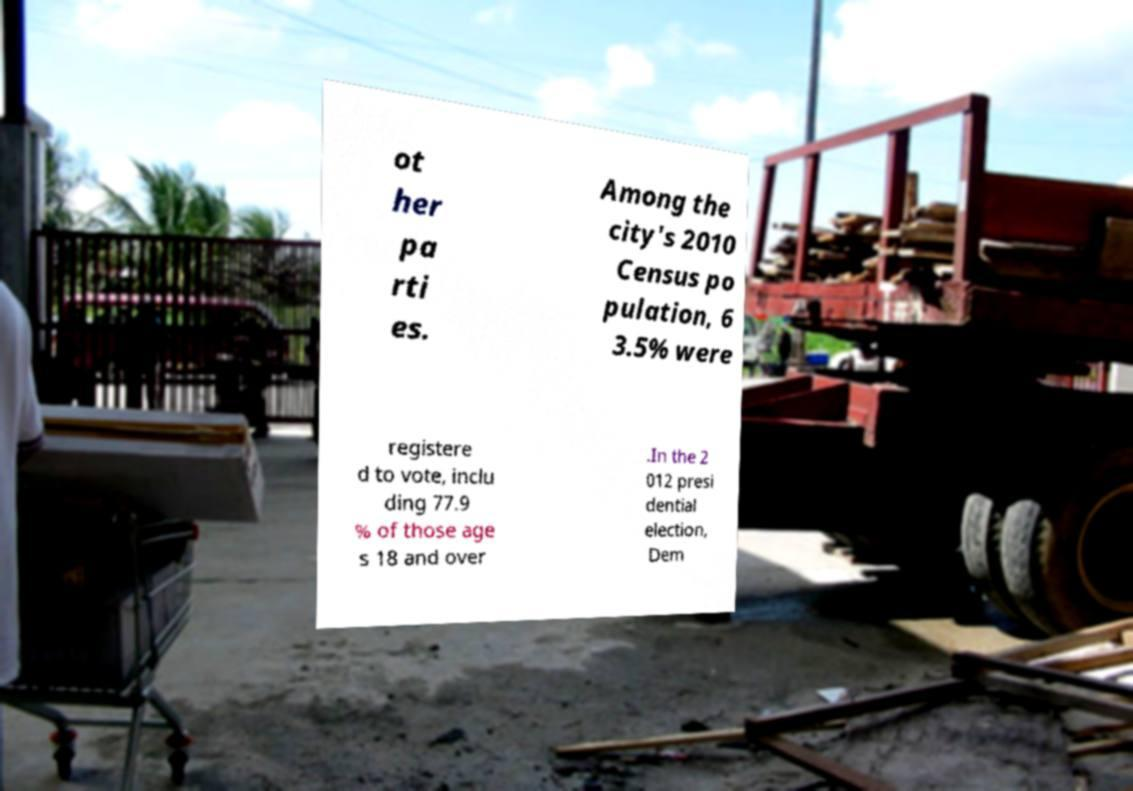Please identify and transcribe the text found in this image. ot her pa rti es. Among the city's 2010 Census po pulation, 6 3.5% were registere d to vote, inclu ding 77.9 % of those age s 18 and over .In the 2 012 presi dential election, Dem 